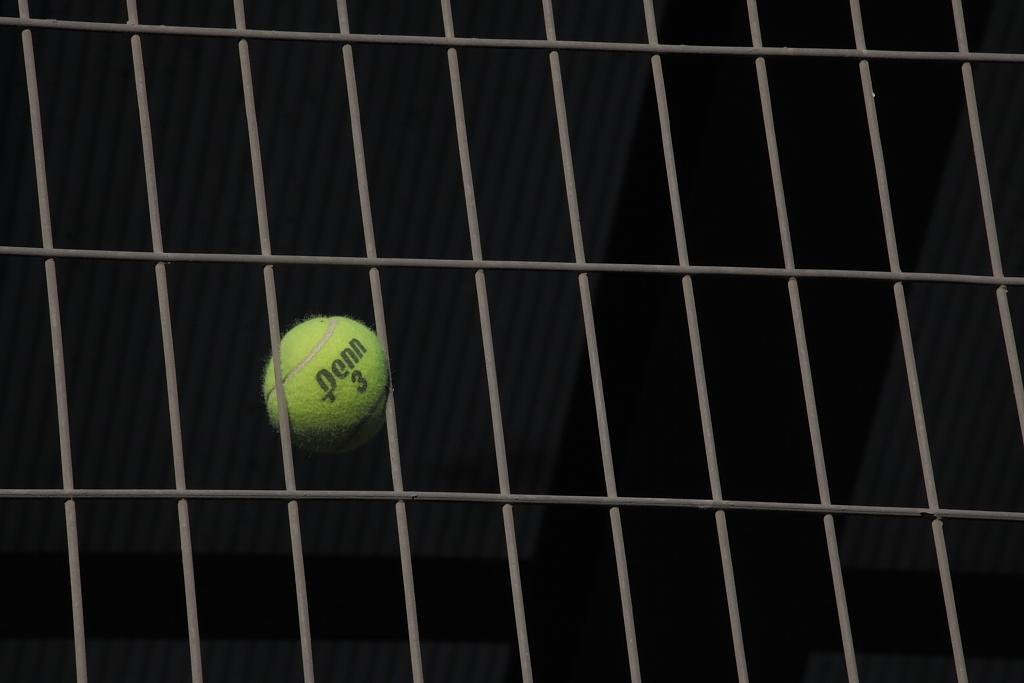What object is the main subject of the image? There is a tennis ball in the image. What else can be seen in the image besides the tennis ball? There appears to be a fencing sheet in the image. How would you describe the lighting in the image? The background of the image is dark. What type of flower can be seen blooming in the morning in the image? There is no flower or indication of morning in the image; it features a tennis ball and a fencing sheet with a dark background. 